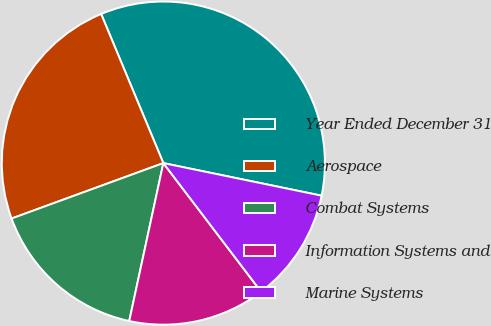<chart> <loc_0><loc_0><loc_500><loc_500><pie_chart><fcel>Year Ended December 31<fcel>Aerospace<fcel>Combat Systems<fcel>Information Systems and<fcel>Marine Systems<nl><fcel>34.52%<fcel>24.28%<fcel>16.04%<fcel>13.73%<fcel>11.42%<nl></chart> 